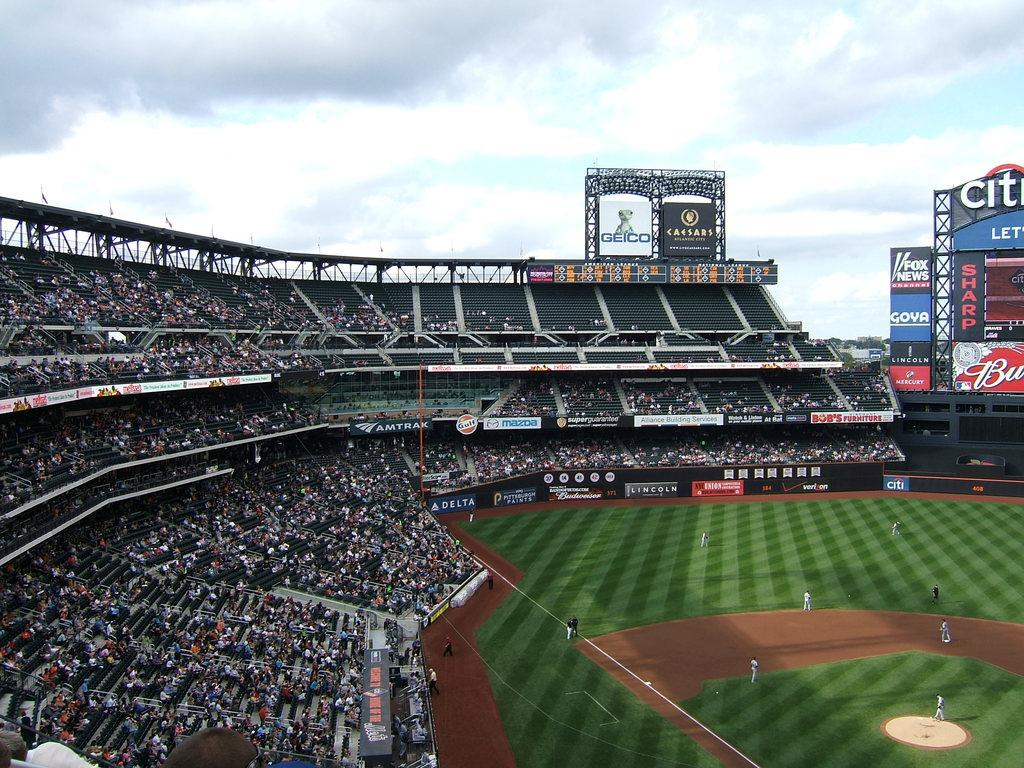<image>
Summarize the visual content of the image. A geico commercial on a billboard during a baseball game 